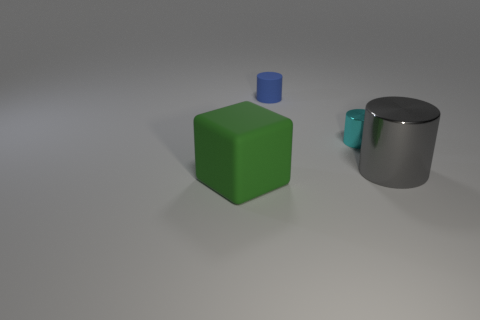Add 4 small blue matte objects. How many objects exist? 8 Subtract all blocks. How many objects are left? 3 Subtract 1 gray cylinders. How many objects are left? 3 Subtract all tiny cyan shiny cylinders. Subtract all tiny objects. How many objects are left? 1 Add 2 big rubber things. How many big rubber things are left? 3 Add 1 large yellow matte things. How many large yellow matte things exist? 1 